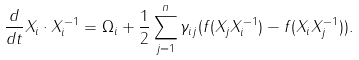Convert formula to latex. <formula><loc_0><loc_0><loc_500><loc_500>\frac { d } { d t } X _ { i } \cdot X _ { i } ^ { - 1 } = \Omega _ { i } + \frac { 1 } { 2 } \sum _ { j = 1 } ^ { n } \gamma _ { i j } ( f ( X _ { j } X _ { i } ^ { - 1 } ) - f ( X _ { i } X _ { j } ^ { - 1 } ) ) .</formula> 